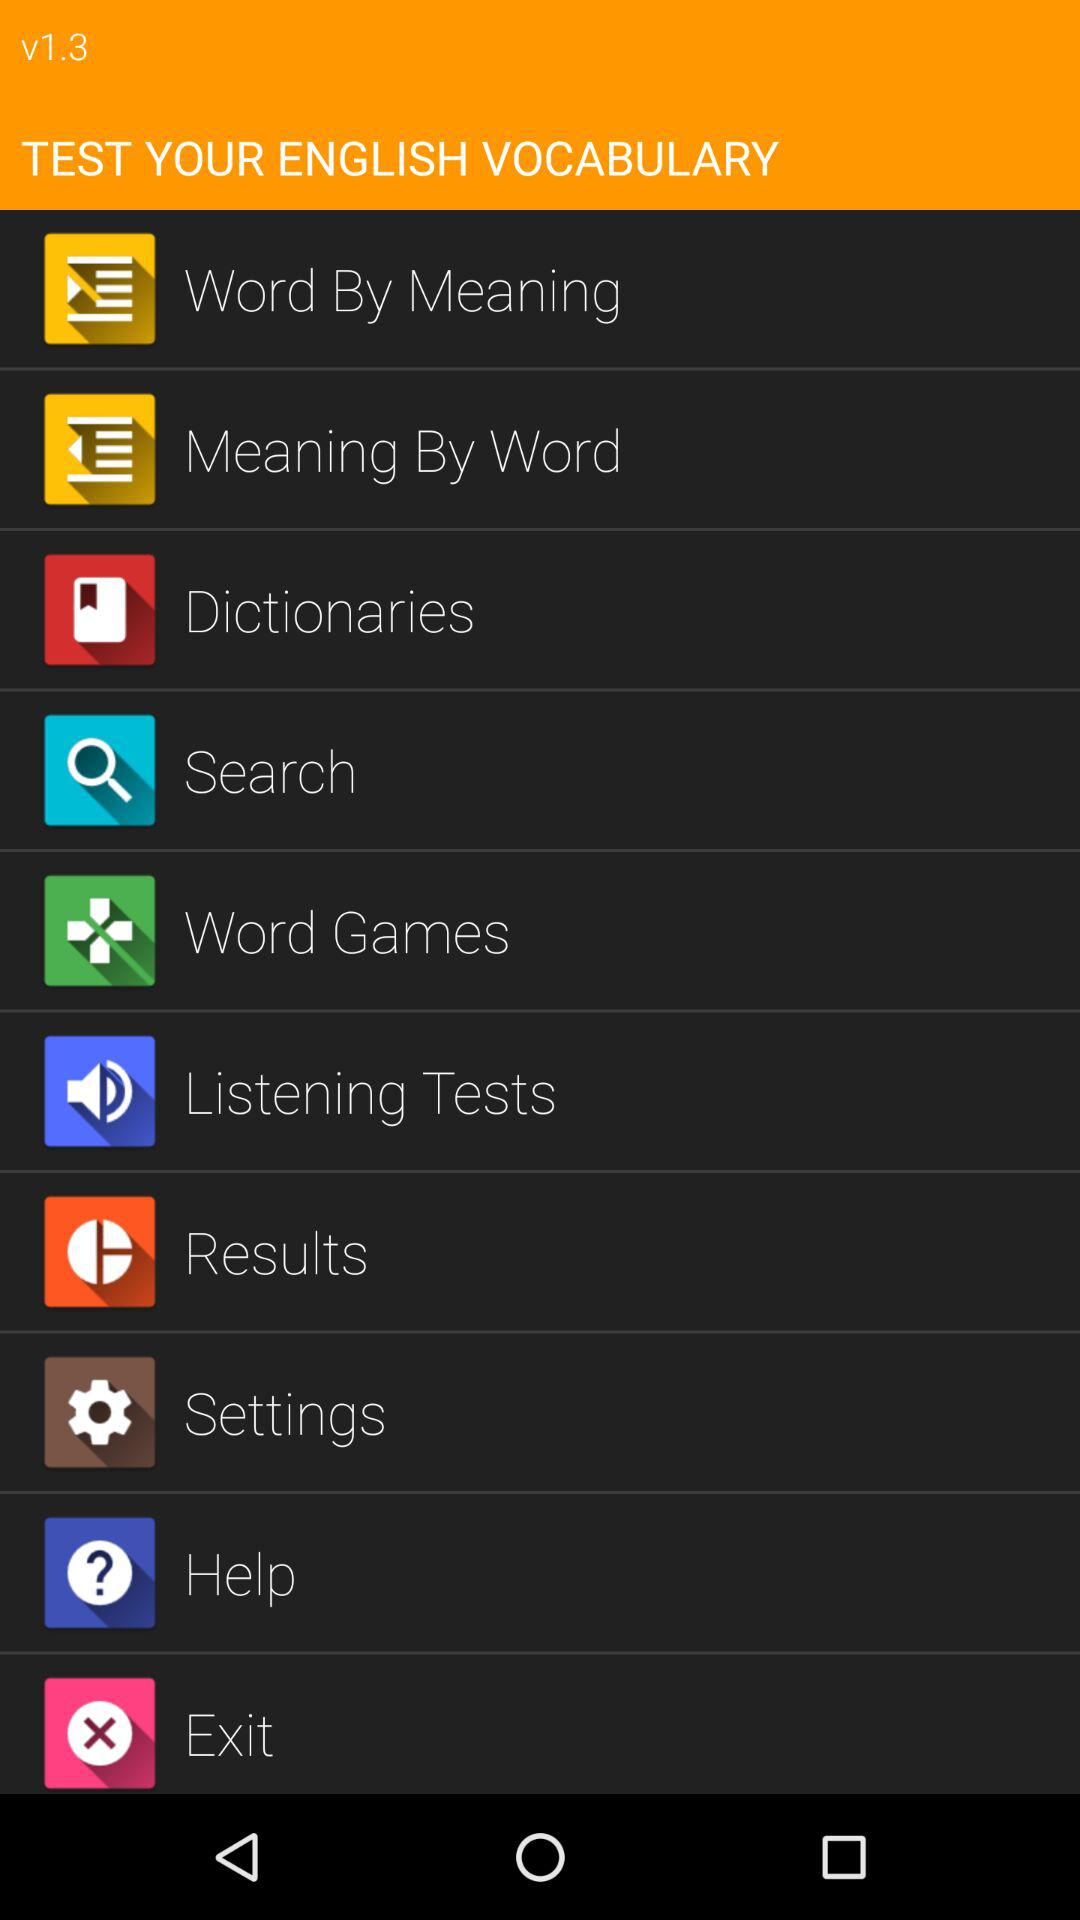How many notifications are there in "Settings"?
When the provided information is insufficient, respond with <no answer>. <no answer> 